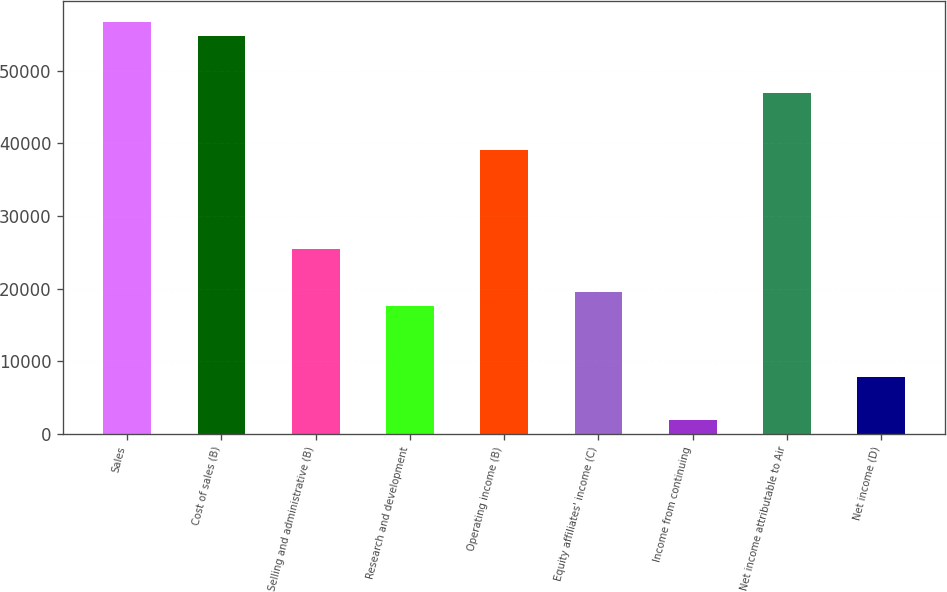<chart> <loc_0><loc_0><loc_500><loc_500><bar_chart><fcel>Sales<fcel>Cost of sales (B)<fcel>Selling and administrative (B)<fcel>Research and development<fcel>Operating income (B)<fcel>Equity affiliates' income (C)<fcel>Income from continuing<fcel>Net income attributable to Air<fcel>Net income (D)<nl><fcel>56682.2<fcel>54727.8<fcel>25411.3<fcel>17593.6<fcel>39092.3<fcel>19548<fcel>1958.14<fcel>46910<fcel>7821.43<nl></chart> 